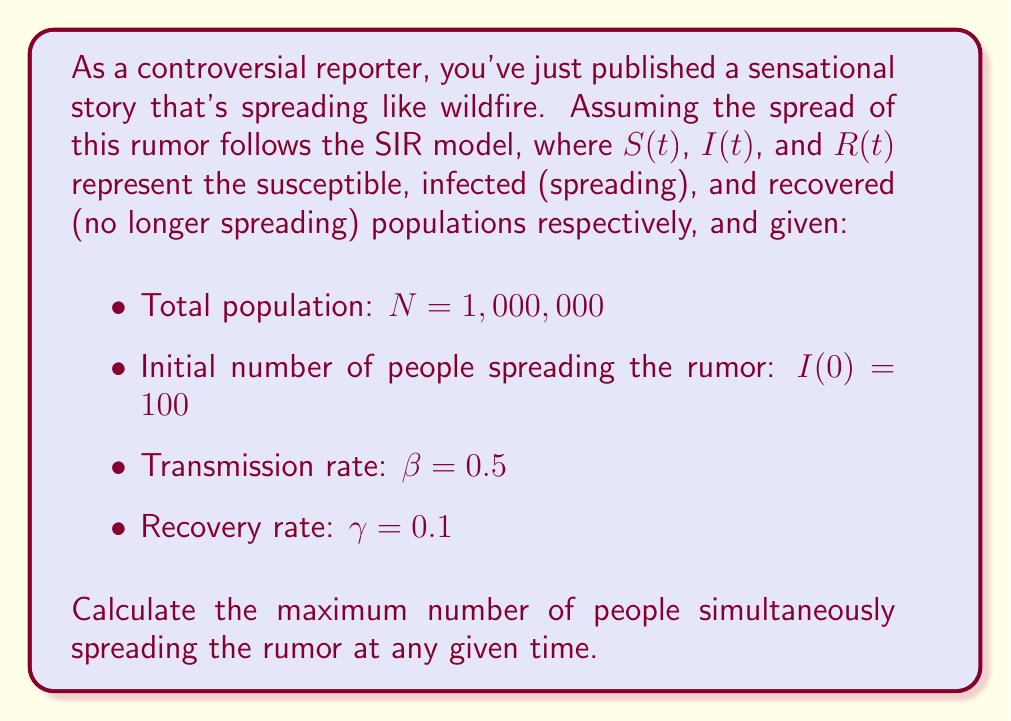Show me your answer to this math problem. To solve this problem, we need to use the SIR model equations and find the peak of the $I(t)$ curve. The SIR model is described by the following differential equations:

$$\begin{align}
\frac{dS}{dt} &= -\beta \frac{SI}{N} \\
\frac{dI}{dt} &= \beta \frac{SI}{N} - \gamma I \\
\frac{dR}{dt} &= \gamma I
\end{align}$$

The peak of $I(t)$ occurs when $\frac{dI}{dt} = 0$. At this point:

$$\beta \frac{SI}{N} - \gamma I = 0$$

Solving for $S$:

$$S = \frac{\gamma N}{\beta} = \frac{0.1 \cdot 1,000,000}{0.5} = 200,000$$

This is known as the critical threshold. When the number of susceptible individuals drops below this value, the rumor starts to die out.

To find the maximum value of $I$, we can use the conservation of population:

$$N = S + I + R$$

At the start of the outbreak, $R(0) \approx 0$, so:

$$S(0) = N - I(0) = 1,000,000 - 100 = 999,900$$

We can use another conservation equation:

$$S + I + R = S(0) + I(0)$$

At the peak of $I$:

$$200,000 + I_{max} + R = 999,900 + 100$$

Solving for $I_{max}$:

$$I_{max} = 999,900 + 100 - 200,000 - R = 800,000 - R$$

To find $R$, we can use the equation:

$$\frac{dS}{dR} = -\frac{\beta S}{\gamma N}$$

Integrating from the initial state to the peak:

$$\int_{S(0)}^{S_{peak}} \frac{dS}{S} = -\frac{\beta}{\gamma N} \int_0^R dR$$

$$\ln\left(\frac{200,000}{999,900}\right) = -\frac{0.5}{0.1 \cdot 1,000,000} R$$

Solving for $R$:

$$R = 200,000 \ln\left(\frac{999,900}{200,000}\right) \approx 320,000$$

Therefore:

$$I_{max} = 800,000 - 320,000 = 480,000$$
Answer: The maximum number of people simultaneously spreading the rumor is approximately 480,000. 